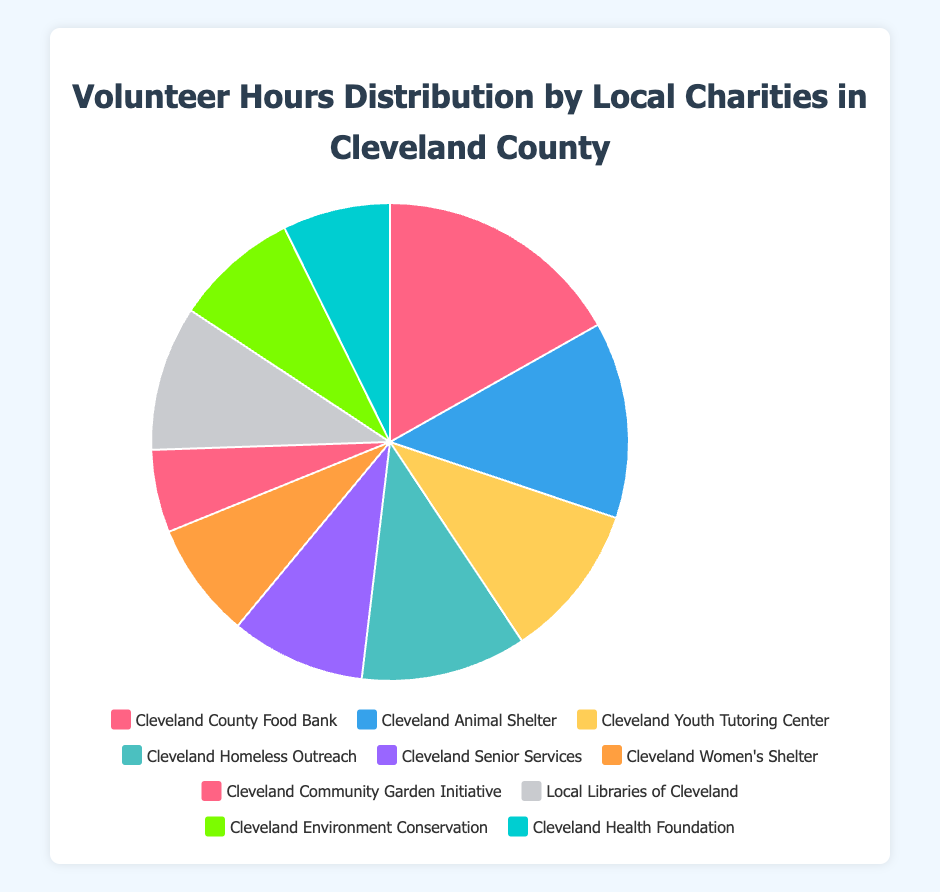Which charity received the most volunteer hours? The figure displays the distribution of volunteer hours among charities. Cleveland County Food Bank has the largest slice, indicating it received the most volunteer hours.
Answer: Cleveland County Food Bank Which charity received fewer volunteer hours than Cleveland Youth Tutoring Center but more than Local Libraries of Cleveland? Cleveland Youth Tutoring Center received 750 hours, whereas Local Libraries of Cleveland received 700. Cleveland Homeless Outreach received 800 hours, fitting the condition of being between these two.
Answer: Cleveland Homeless Outreach What is the total number of volunteer hours for Cleveland Youth Tutoring Center and Cleveland Senior Services combined? Cleveland Youth Tutoring Center has 750 hours and Cleveland Senior Services has 650 hours. Adding these gives 750 + 650 = 1400 hours.
Answer: 1400 hours Which charities received more than 600 volunteer hours? By looking at the sizes of the slices and their corresponding labels, the charities with more than 600 hours are Cleveland County Food Bank, Cleveland Animal Shelter, Cleveland Youth Tutoring Center, Cleveland Homeless Outreach, and Local Libraries of Cleveland.
Answer: Cleveland County Food Bank, Cleveland Animal Shelter, Cleveland Youth Tutoring Center, Cleveland Homeless Outreach, Local Libraries of Cleveland What is the total number of volunteer hours contributed to Cleveland Women’s Shelter and Cleveland Health Foundation combined? Cleveland Women’s Shelter contributed 560 hours and Cleveland Health Foundation contributed 520 hours. Adding these gives 560 + 520 = 1080 hours.
Answer: 1080 hours How does Cleveland County Food Bank’s volunteer hours compare to Cleveland Animal Shelter's? Cleveland County Food Bank has 1200 hours and Cleveland Animal Shelter has 950 hours. 1200 is greater than 950.
Answer: Greater than What is the color associated with the Cleveland Community Garden Initiative slice? By observing the color legend, the Cleveland Community Garden Initiative slice is the one in orange (sixth slice).
Answer: Orange Which charity received the least volunteer hours? The smallest slice in the pie chart corresponds to Cleveland Community Garden Initiative, meaning it received the least volunteer hours.
Answer: Cleveland Community Garden Initiative How many more hours did the Cleveland County Food Bank receive compared to the Cleveland Senior Services? Cleveland County Food Bank has 1200 hours and Cleveland Senior Services has 650 hours. The difference is 1200 - 650 = 550 hours.
Answer: 550 hours 